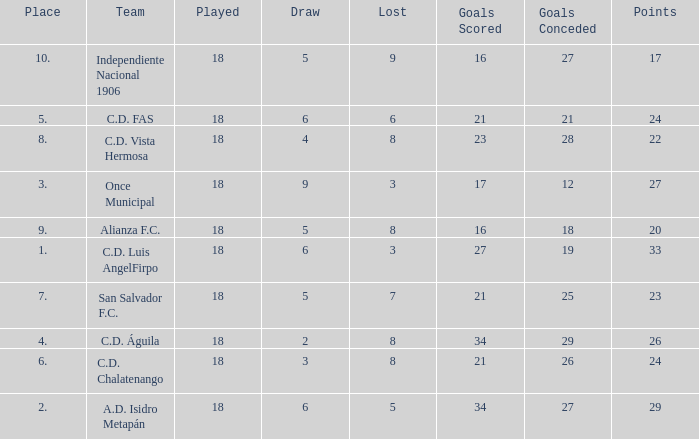How many points were in a game that had a lost of 5, greater than place 2, and 27 goals conceded? 0.0. Give me the full table as a dictionary. {'header': ['Place', 'Team', 'Played', 'Draw', 'Lost', 'Goals Scored', 'Goals Conceded', 'Points'], 'rows': [['10.', 'Independiente Nacional 1906', '18', '5', '9', '16', '27', '17'], ['5.', 'C.D. FAS', '18', '6', '6', '21', '21', '24'], ['8.', 'C.D. Vista Hermosa', '18', '4', '8', '23', '28', '22'], ['3.', 'Once Municipal', '18', '9', '3', '17', '12', '27'], ['9.', 'Alianza F.C.', '18', '5', '8', '16', '18', '20'], ['1.', 'C.D. Luis AngelFirpo', '18', '6', '3', '27', '19', '33'], ['7.', 'San Salvador F.C.', '18', '5', '7', '21', '25', '23'], ['4.', 'C.D. Águila', '18', '2', '8', '34', '29', '26'], ['6.', 'C.D. Chalatenango', '18', '3', '8', '21', '26', '24'], ['2.', 'A.D. Isidro Metapán', '18', '6', '5', '34', '27', '29']]} 